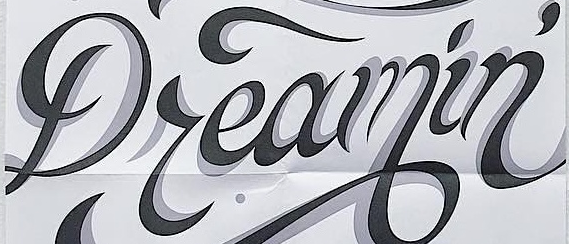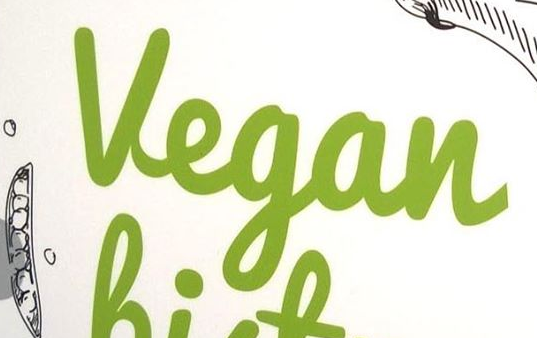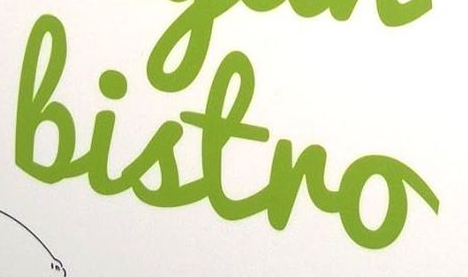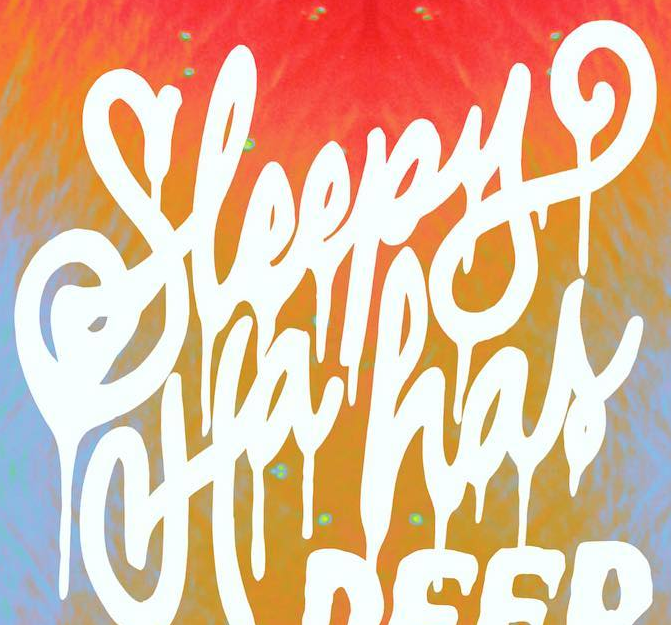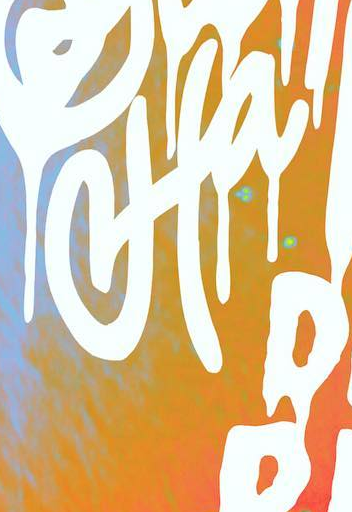What text appears in these images from left to right, separated by a semicolon? Dreamin'; Vegan; Bistro; Sleepy; Ha 